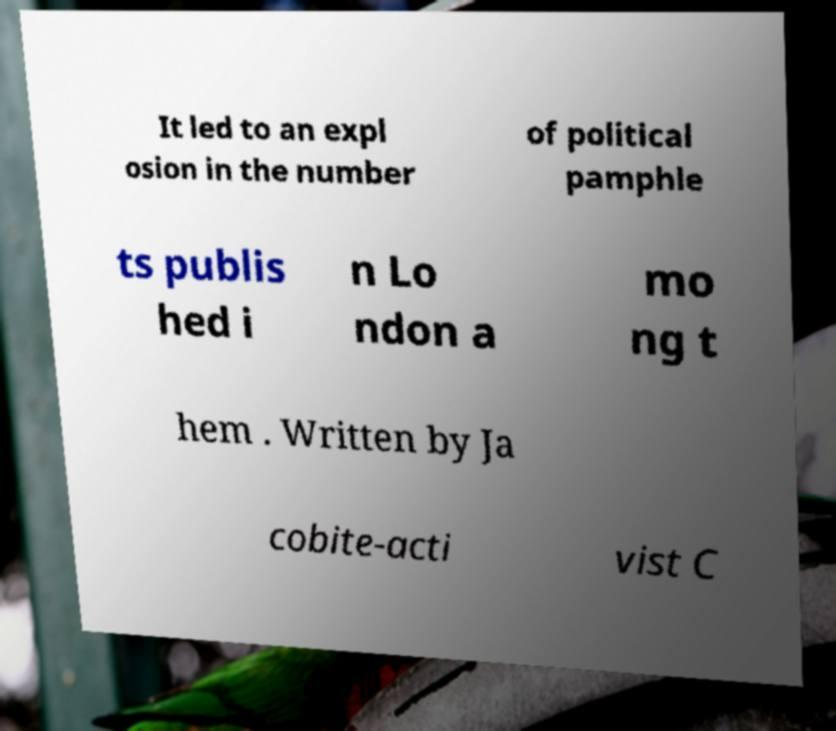Can you accurately transcribe the text from the provided image for me? It led to an expl osion in the number of political pamphle ts publis hed i n Lo ndon a mo ng t hem . Written by Ja cobite-acti vist C 